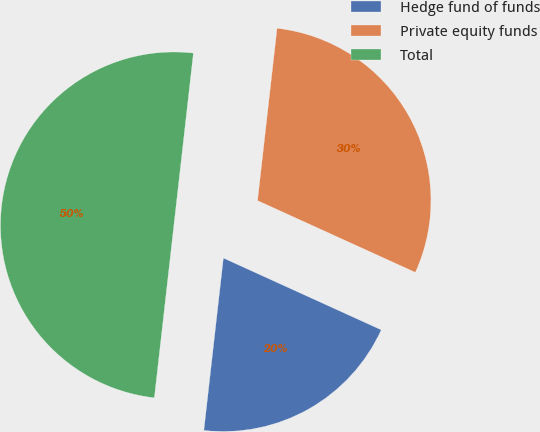Convert chart to OTSL. <chart><loc_0><loc_0><loc_500><loc_500><pie_chart><fcel>Hedge fund of funds<fcel>Private equity funds<fcel>Total<nl><fcel>20.0%<fcel>30.0%<fcel>50.0%<nl></chart> 